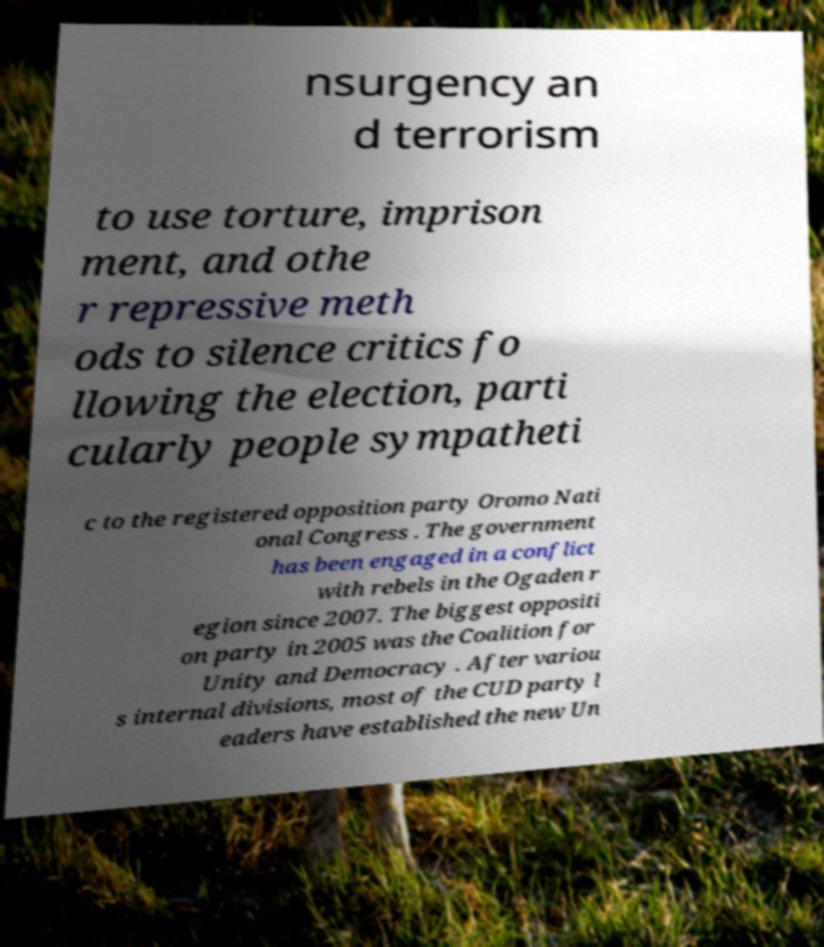Can you accurately transcribe the text from the provided image for me? nsurgency an d terrorism to use torture, imprison ment, and othe r repressive meth ods to silence critics fo llowing the election, parti cularly people sympatheti c to the registered opposition party Oromo Nati onal Congress . The government has been engaged in a conflict with rebels in the Ogaden r egion since 2007. The biggest oppositi on party in 2005 was the Coalition for Unity and Democracy . After variou s internal divisions, most of the CUD party l eaders have established the new Un 